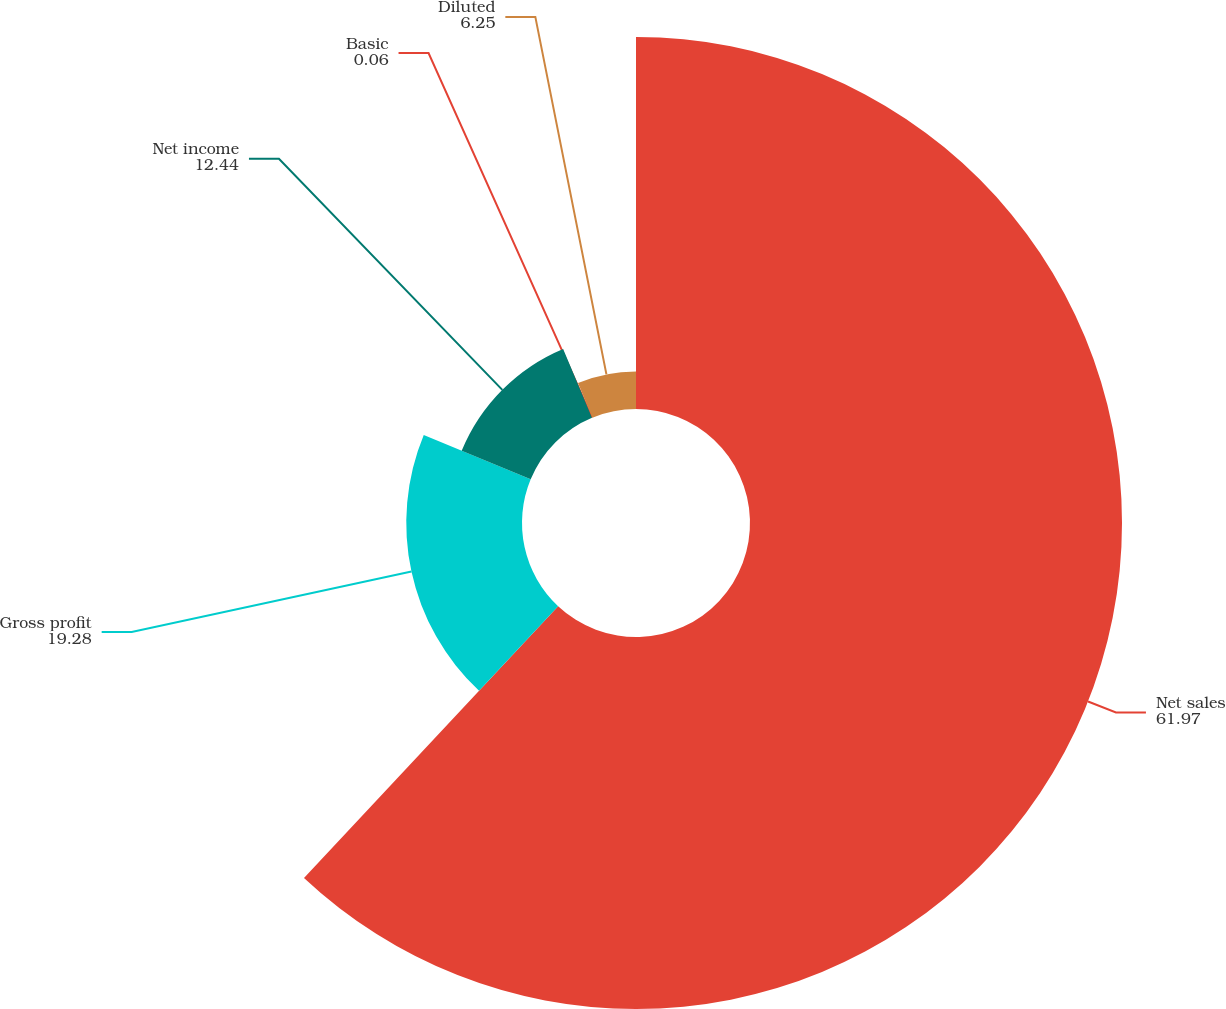<chart> <loc_0><loc_0><loc_500><loc_500><pie_chart><fcel>Net sales<fcel>Gross profit<fcel>Net income<fcel>Basic<fcel>Diluted<nl><fcel>61.97%<fcel>19.28%<fcel>12.44%<fcel>0.06%<fcel>6.25%<nl></chart> 